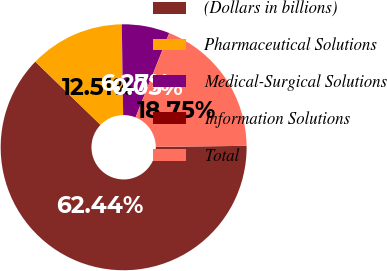<chart> <loc_0><loc_0><loc_500><loc_500><pie_chart><fcel>(Dollars in billions)<fcel>Pharmaceutical Solutions<fcel>Medical-Surgical Solutions<fcel>Information Solutions<fcel>Total<nl><fcel>62.43%<fcel>12.51%<fcel>6.27%<fcel>0.03%<fcel>18.75%<nl></chart> 